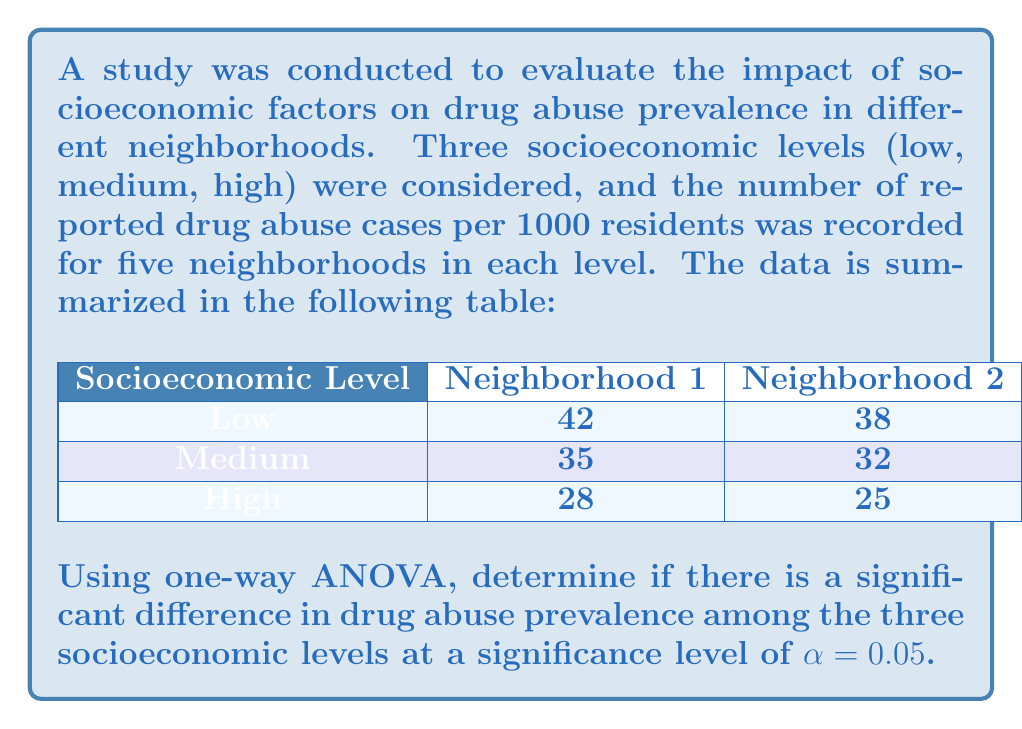Help me with this question. Let's approach this step-by-step:

1) First, we need to calculate the sum of squares:

   a) Total Sum of Squares (SST):
      $$SST = \sum_{i=1}^{n} (x_i - \bar{x})^2$$
      where $x_i$ are all individual values and $\bar{x}$ is the grand mean.

   b) Between-group Sum of Squares (SSB):
      $$SSB = \sum_{i=1}^{k} n_i(\bar{x}_i - \bar{x})^2$$
      where $k$ is the number of groups, $n_i$ is the size of each group, and $\bar{x}_i$ is the mean of each group.

   c) Within-group Sum of Squares (SSW):
      $$SSW = SST - SSB$$

2) Calculate degrees of freedom:
   - Total df: $n - 1 = 15 - 1 = 14$
   - Between-group df: $k - 1 = 3 - 1 = 2$
   - Within-group df: $n - k = 15 - 3 = 12$

3) Calculate Mean Squares:
   $$MSB = \frac{SSB}{df_B}$$
   $$MSW = \frac{SSW}{df_W}$$

4) Calculate F-statistic:
   $$F = \frac{MSB}{MSW}$$

5) Compare F-statistic with critical F-value:
   $F_{critical} = F_{0.05, 2, 12}$ (from F-distribution table)

6) If $F > F_{critical}$, reject the null hypothesis.

Performing these calculations:

SST = 614.9333
SSB = 561.7333
SSW = 53.2000

MSB = 280.8667
MSW = 4.4333

F = 63.3534

$F_{critical} = 3.8853$

Since $63.3534 > 3.8853$, we reject the null hypothesis.
Answer: There is a significant difference in drug abuse prevalence among the three socioeconomic levels (F(2,12) = 63.3534, p < 0.05). 